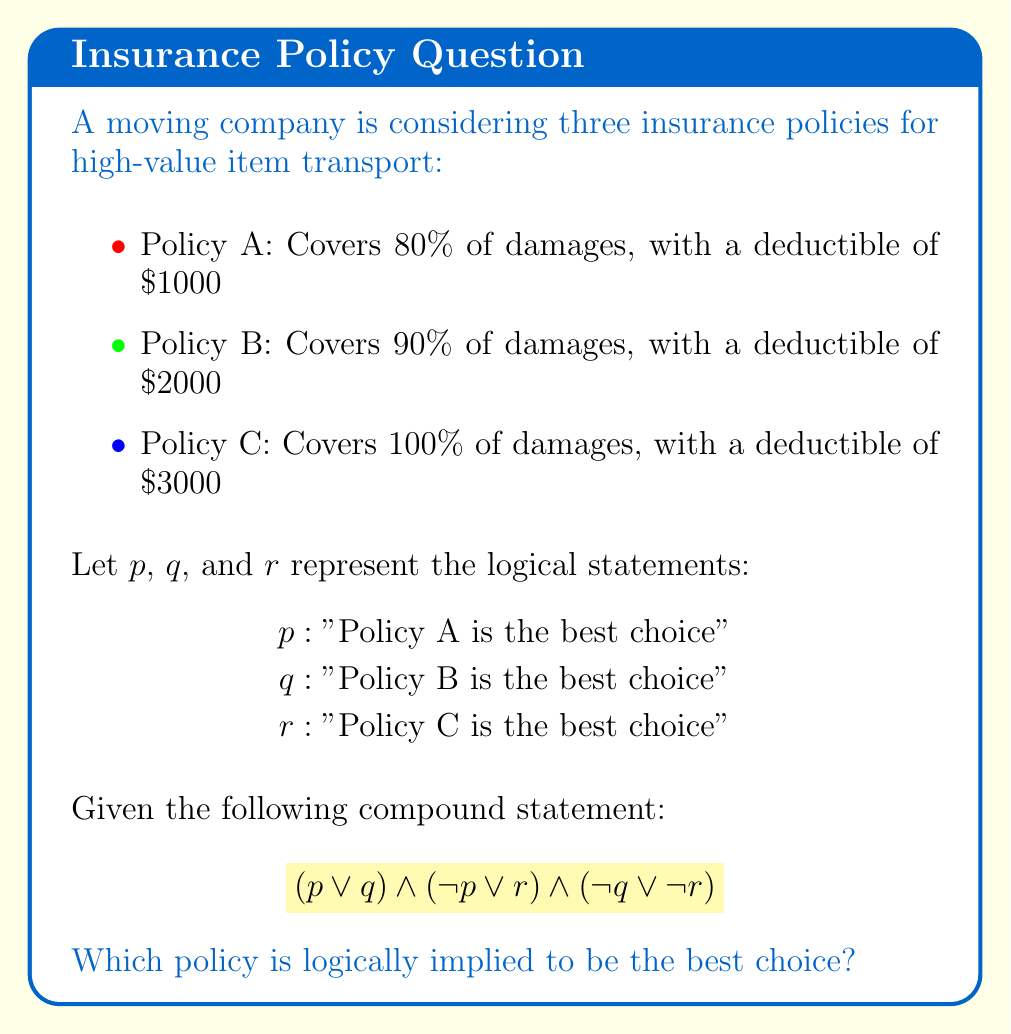What is the answer to this math problem? Let's approach this step-by-step using a truth table:

1) First, we'll evaluate each part of the compound statement:
   $(p \lor q)$, $(\lnot p \lor r)$, and $(\lnot q \lor \lnot r)$

2) Then, we'll combine these using the AND operator $\land$

3) Here's the truth table:

   | $p$ | $q$ | $r$ | $(p \lor q)$ | $(\lnot p \lor r)$ | $(\lnot q \lor \lnot r)$ | Result |
   |-----|-----|-----|--------------|---------------------|--------------------------|--------|
   | T   | T   | T   | T            | T                   | F                        | F      |
   | T   | T   | F   | T            | F                   | T                        | F      |
   | T   | F   | T   | T            | T                   | T                        | T      |
   | T   | F   | F   | T            | F                   | T                        | F      |
   | F   | T   | T   | T            | T                   | F                        | F      |
   | F   | T   | F   | T            | T                   | T                        | T      |
   | F   | F   | T   | F            | T                   | T                        | F      |
   | F   | F   | F   | F            | T                   | T                        | F      |

4) From the truth table, we can see that the compound statement is true in two cases:
   - When $p$ is true, $q$ is false, and $r$ is true
   - When $p$ is false, $q$ is true, and $r$ is false

5) However, these two cases are mutually exclusive. They can't both be true at the same time.

6) Given that we must choose one policy, and the question asks which policy is logically implied to be the best choice, we need to look for a common element in both true cases.

7) We can see that in both cases where the compound statement is true, $q$ (Policy B) is the opposite of $p$ and $r$.

8) This implies that if either $p$ or $r$ is true, $q$ must be false, and if $q$ is true, both $p$ and $r$ must be false.

9) Therefore, the compound statement logically implies that Policy B cannot be the best choice.

10) By process of elimination, we can conclude that the statement logically implies either Policy A or Policy C could be the best choice, but it doesn't specify which one.
Answer: Either Policy A or Policy C 